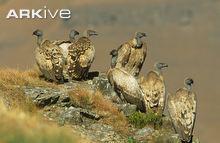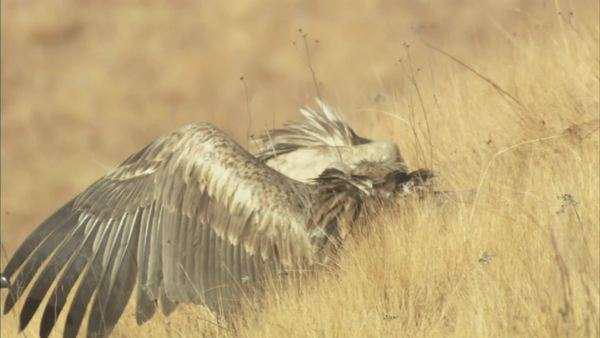The first image is the image on the left, the second image is the image on the right. For the images shown, is this caption "In at least one image there is a single vulture on the ground with it wings expanded." true? Answer yes or no. Yes. The first image is the image on the left, the second image is the image on the right. Considering the images on both sides, is "It does not appear as though our fine feathered friends are eating right now." valid? Answer yes or no. Yes. 